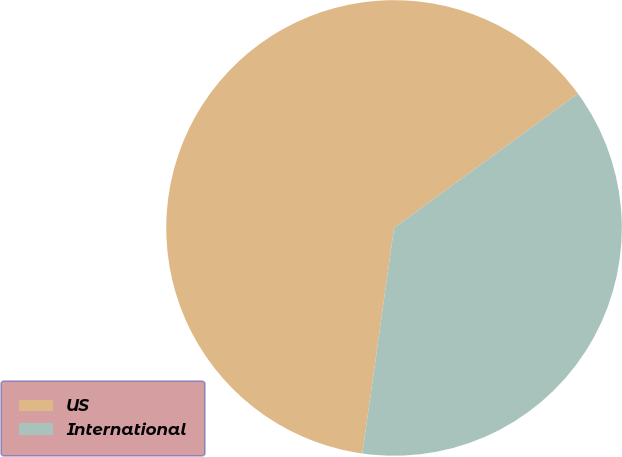Convert chart. <chart><loc_0><loc_0><loc_500><loc_500><pie_chart><fcel>US<fcel>International<nl><fcel>62.74%<fcel>37.26%<nl></chart> 